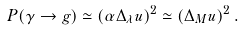<formula> <loc_0><loc_0><loc_500><loc_500>P ( \gamma \rightarrow g ) \simeq \left ( \alpha \Delta _ { \lambda } u \right ) ^ { 2 } \simeq \left ( \Delta _ { M } u \right ) ^ { 2 } .</formula> 